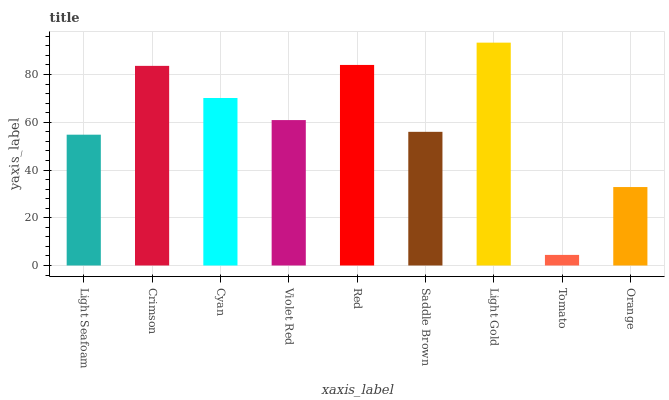Is Crimson the minimum?
Answer yes or no. No. Is Crimson the maximum?
Answer yes or no. No. Is Crimson greater than Light Seafoam?
Answer yes or no. Yes. Is Light Seafoam less than Crimson?
Answer yes or no. Yes. Is Light Seafoam greater than Crimson?
Answer yes or no. No. Is Crimson less than Light Seafoam?
Answer yes or no. No. Is Violet Red the high median?
Answer yes or no. Yes. Is Violet Red the low median?
Answer yes or no. Yes. Is Light Seafoam the high median?
Answer yes or no. No. Is Crimson the low median?
Answer yes or no. No. 